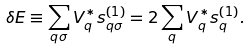Convert formula to latex. <formula><loc_0><loc_0><loc_500><loc_500>\delta E \equiv \sum _ { q \sigma } V _ { q } ^ { * } s _ { q \sigma } ^ { ( 1 ) } = 2 \sum _ { q } V _ { q } ^ { * } s _ { q } ^ { ( 1 ) } .</formula> 